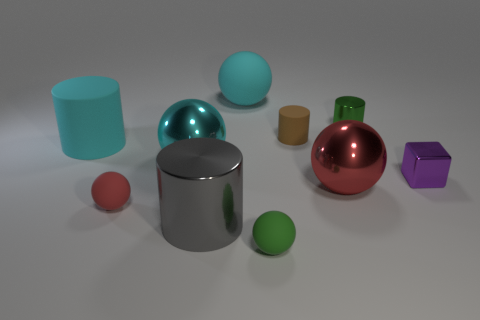Subtract all gray cylinders. How many cylinders are left? 3 Subtract all large cyan rubber spheres. How many spheres are left? 4 Subtract 1 cylinders. How many cylinders are left? 3 Add 3 large gray metal things. How many large gray metal things are left? 4 Add 3 large rubber spheres. How many large rubber spheres exist? 4 Subtract 0 blue balls. How many objects are left? 10 Subtract all cylinders. How many objects are left? 6 Subtract all red balls. Subtract all green cylinders. How many balls are left? 3 Subtract all brown blocks. How many green cylinders are left? 1 Subtract all tiny purple shiny objects. Subtract all gray shiny objects. How many objects are left? 8 